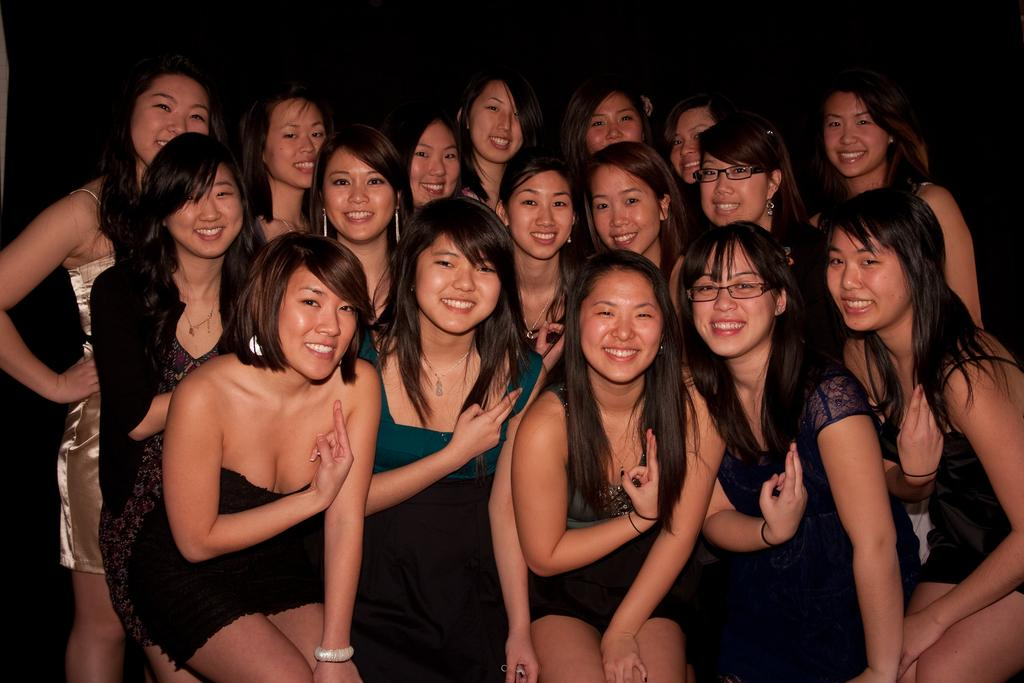What is the main subject of the image? The main subject of the image is a group of young girls. What are the girls doing in the image? The girls are standing and smiling. Who or what might the girls be smiling at? They appear to be smiling at someone or something. What type of fruit can be seen in the image? There is no fruit present in the image. Is there a cart visible in the image? No, there is no cart present in the image. 